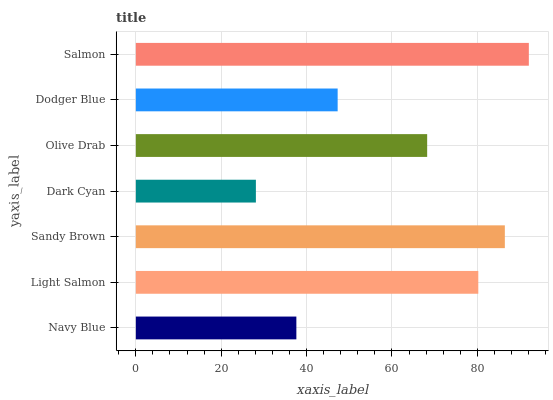Is Dark Cyan the minimum?
Answer yes or no. Yes. Is Salmon the maximum?
Answer yes or no. Yes. Is Light Salmon the minimum?
Answer yes or no. No. Is Light Salmon the maximum?
Answer yes or no. No. Is Light Salmon greater than Navy Blue?
Answer yes or no. Yes. Is Navy Blue less than Light Salmon?
Answer yes or no. Yes. Is Navy Blue greater than Light Salmon?
Answer yes or no. No. Is Light Salmon less than Navy Blue?
Answer yes or no. No. Is Olive Drab the high median?
Answer yes or no. Yes. Is Olive Drab the low median?
Answer yes or no. Yes. Is Salmon the high median?
Answer yes or no. No. Is Light Salmon the low median?
Answer yes or no. No. 